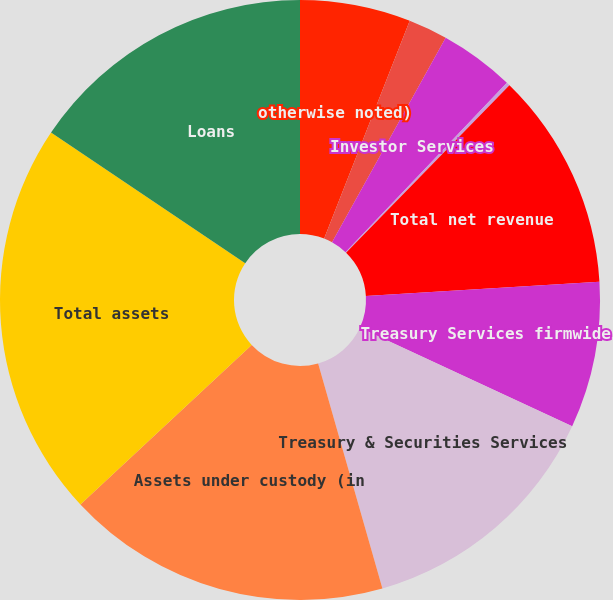Convert chart to OTSL. <chart><loc_0><loc_0><loc_500><loc_500><pie_chart><fcel>otherwise noted)<fcel>Treasury Services (b)<fcel>Investor Services<fcel>Institutional Trust Services<fcel>Total net revenue<fcel>Treasury Services firmwide<fcel>Treasury & Securities Services<fcel>Assets under custody (in<fcel>Total assets<fcel>Loans<nl><fcel>5.96%<fcel>2.11%<fcel>4.04%<fcel>0.19%<fcel>11.73%<fcel>7.88%<fcel>13.66%<fcel>17.5%<fcel>21.35%<fcel>15.58%<nl></chart> 